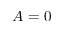Convert formula to latex. <formula><loc_0><loc_0><loc_500><loc_500>A = 0</formula> 